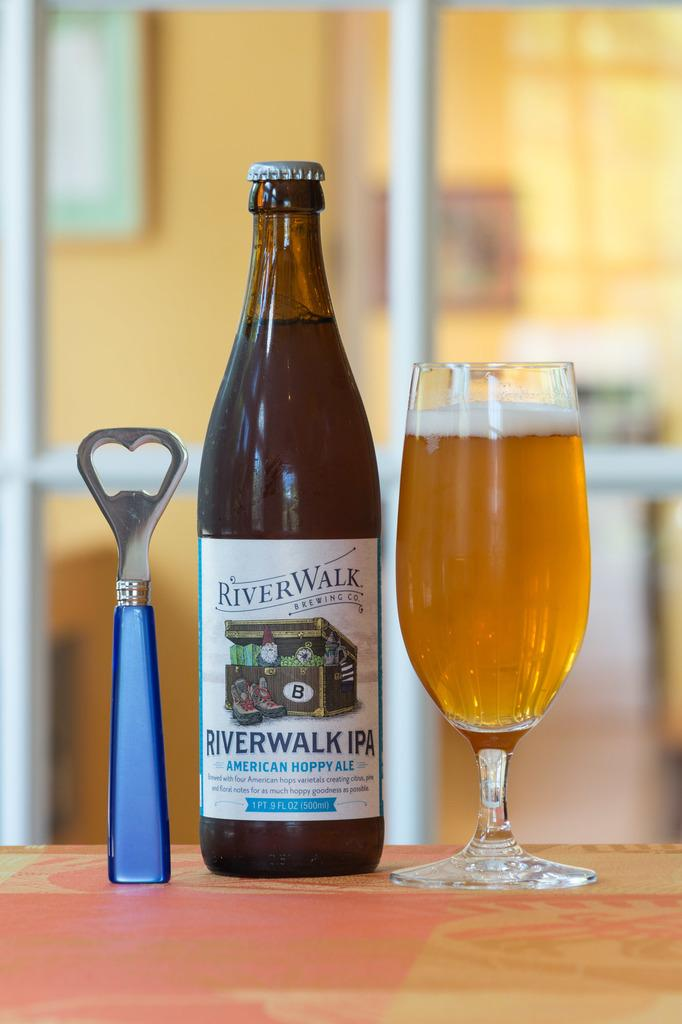Provide a one-sentence caption for the provided image. Bottle of River Walk IPA beer next to a can opener and a cup of beer. 